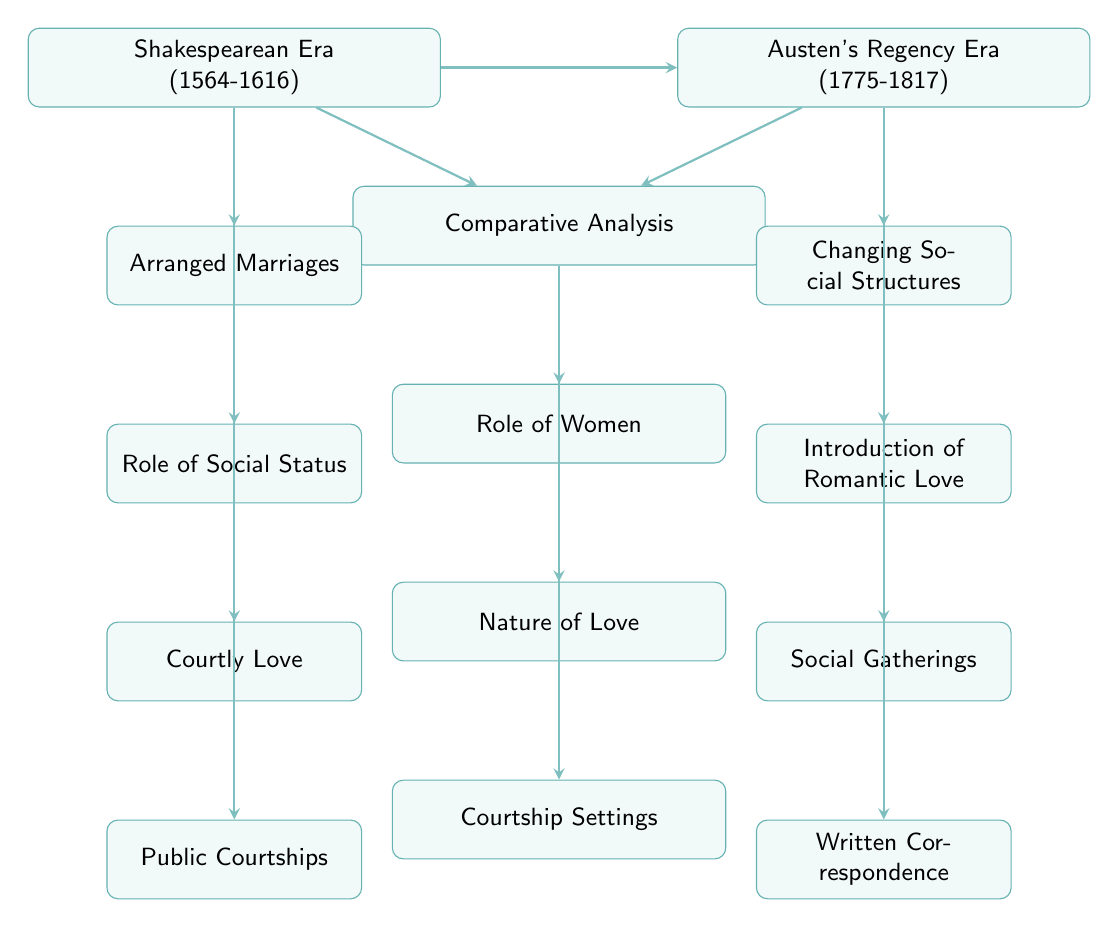What is the first node in the diagram? The first node is labeled "Shakespearean Era (1564-1616)", which is the starting point of the flow chart.
Answer: Shakespearean Era (1564-1616) How many sub-nodes does the Shakespearean Era have? The Shakespearean Era has four sub-nodes, namely "Arranged Marriages", "Role of Social Status", "Courtly Love", and "Public Courtships".
Answer: 4 What attribute is associated with "Introduction of Romantic Love"? The attribute associated with "Introduction of Romantic Love" is "Emphasis on Personal Compatibility".
Answer: Emphasis on Personal Compatibility What is the relationship between "Shakespearean Era" and "Comparative Analysis"? The relationship is a unidirectional flow where the "Shakespearean Era" node points to the "Comparative Analysis" node, indicating a comparative study begins from the understanding of the Shakespearean context.
Answer: Points to Which node highlights the changing role of women from Shakespeare to Austen? The node that highlights this change is "Role of Women". It notes the transition from being submissive in Shakespeare's time to having more agency in Austen's time.
Answer: Role of Women What are two settings mentioned for courtship in Austen's time? The two settings mentioned are "Private and Social Gatherings", specifically referred to as "Social Gatherings" and "Written Correspondence".
Answer: Social Gatherings, Written Correspondence Which sub-node of the Shakespearean Era focuses on public expressions of affection? The sub-node that focuses on public expressions of affection is "Public Courtships", which includes elements like Masques and Public Affections.
Answer: Public Courtships What does the "Comparative Analysis" node culminate in? The "Comparative Analysis" node culminates in understanding the differences among "Role of Women", "Nature of Love", and "Courtship Settings".
Answer: Differences How does the role of social status differ from Shakespeare to Austen? The transition is noted in the node "Social Structures", emphasizing changes from rigid class distinctions in the Shakespearean Era to greater social mobility in Austen's time.
Answer: Greater social mobility 